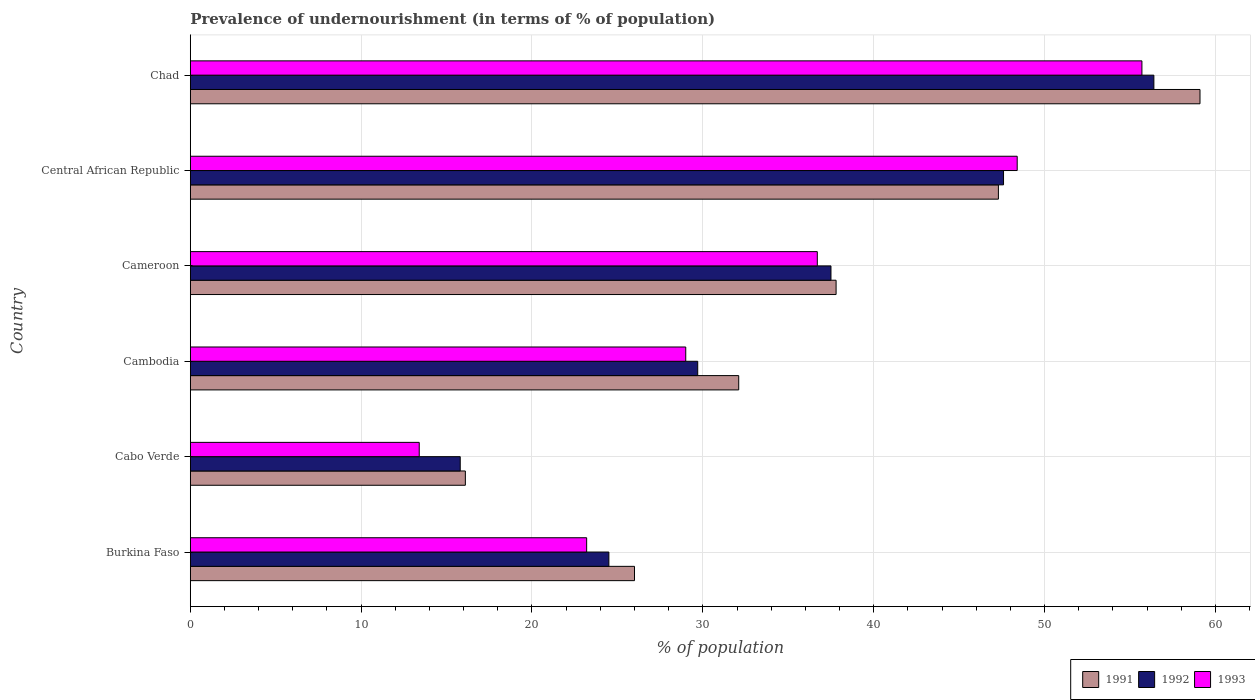How many different coloured bars are there?
Provide a succinct answer. 3. Are the number of bars on each tick of the Y-axis equal?
Make the answer very short. Yes. How many bars are there on the 6th tick from the top?
Provide a short and direct response. 3. How many bars are there on the 6th tick from the bottom?
Your answer should be very brief. 3. What is the label of the 6th group of bars from the top?
Offer a very short reply. Burkina Faso. What is the percentage of undernourished population in 1993 in Cambodia?
Your answer should be compact. 29. Across all countries, what is the maximum percentage of undernourished population in 1992?
Your answer should be very brief. 56.4. Across all countries, what is the minimum percentage of undernourished population in 1991?
Your response must be concise. 16.1. In which country was the percentage of undernourished population in 1993 maximum?
Give a very brief answer. Chad. In which country was the percentage of undernourished population in 1991 minimum?
Make the answer very short. Cabo Verde. What is the total percentage of undernourished population in 1992 in the graph?
Ensure brevity in your answer.  211.5. What is the difference between the percentage of undernourished population in 1993 in Cambodia and that in Central African Republic?
Provide a short and direct response. -19.4. What is the difference between the percentage of undernourished population in 1991 in Cabo Verde and the percentage of undernourished population in 1993 in Cambodia?
Provide a short and direct response. -12.9. What is the average percentage of undernourished population in 1991 per country?
Make the answer very short. 36.4. What is the difference between the percentage of undernourished population in 1992 and percentage of undernourished population in 1991 in Cabo Verde?
Give a very brief answer. -0.3. In how many countries, is the percentage of undernourished population in 1993 greater than 20 %?
Your response must be concise. 5. What is the ratio of the percentage of undernourished population in 1993 in Cambodia to that in Cameroon?
Your answer should be compact. 0.79. Is the percentage of undernourished population in 1992 in Burkina Faso less than that in Cabo Verde?
Your answer should be very brief. No. What is the difference between the highest and the second highest percentage of undernourished population in 1993?
Offer a very short reply. 7.3. What is the difference between the highest and the lowest percentage of undernourished population in 1993?
Provide a short and direct response. 42.3. Is the sum of the percentage of undernourished population in 1993 in Burkina Faso and Cambodia greater than the maximum percentage of undernourished population in 1991 across all countries?
Keep it short and to the point. No. What does the 1st bar from the top in Burkina Faso represents?
Provide a short and direct response. 1993. What does the 2nd bar from the bottom in Chad represents?
Offer a very short reply. 1992. How many bars are there?
Make the answer very short. 18. How many countries are there in the graph?
Your response must be concise. 6. Are the values on the major ticks of X-axis written in scientific E-notation?
Offer a terse response. No. Does the graph contain any zero values?
Provide a succinct answer. No. Where does the legend appear in the graph?
Ensure brevity in your answer.  Bottom right. How many legend labels are there?
Provide a short and direct response. 3. How are the legend labels stacked?
Your answer should be very brief. Horizontal. What is the title of the graph?
Give a very brief answer. Prevalence of undernourishment (in terms of % of population). What is the label or title of the X-axis?
Your answer should be very brief. % of population. What is the % of population of 1992 in Burkina Faso?
Your response must be concise. 24.5. What is the % of population of 1993 in Burkina Faso?
Your response must be concise. 23.2. What is the % of population in 1991 in Cambodia?
Give a very brief answer. 32.1. What is the % of population of 1992 in Cambodia?
Offer a terse response. 29.7. What is the % of population in 1991 in Cameroon?
Provide a succinct answer. 37.8. What is the % of population of 1992 in Cameroon?
Provide a short and direct response. 37.5. What is the % of population of 1993 in Cameroon?
Provide a short and direct response. 36.7. What is the % of population of 1991 in Central African Republic?
Your answer should be compact. 47.3. What is the % of population in 1992 in Central African Republic?
Give a very brief answer. 47.6. What is the % of population of 1993 in Central African Republic?
Ensure brevity in your answer.  48.4. What is the % of population in 1991 in Chad?
Provide a succinct answer. 59.1. What is the % of population of 1992 in Chad?
Offer a terse response. 56.4. What is the % of population of 1993 in Chad?
Make the answer very short. 55.7. Across all countries, what is the maximum % of population in 1991?
Give a very brief answer. 59.1. Across all countries, what is the maximum % of population of 1992?
Ensure brevity in your answer.  56.4. Across all countries, what is the maximum % of population of 1993?
Your answer should be very brief. 55.7. Across all countries, what is the minimum % of population in 1991?
Keep it short and to the point. 16.1. Across all countries, what is the minimum % of population of 1993?
Offer a terse response. 13.4. What is the total % of population in 1991 in the graph?
Keep it short and to the point. 218.4. What is the total % of population in 1992 in the graph?
Keep it short and to the point. 211.5. What is the total % of population in 1993 in the graph?
Your answer should be very brief. 206.4. What is the difference between the % of population of 1992 in Burkina Faso and that in Cabo Verde?
Provide a succinct answer. 8.7. What is the difference between the % of population of 1991 in Burkina Faso and that in Cambodia?
Give a very brief answer. -6.1. What is the difference between the % of population of 1991 in Burkina Faso and that in Cameroon?
Offer a very short reply. -11.8. What is the difference between the % of population in 1992 in Burkina Faso and that in Cameroon?
Provide a succinct answer. -13. What is the difference between the % of population of 1993 in Burkina Faso and that in Cameroon?
Provide a succinct answer. -13.5. What is the difference between the % of population in 1991 in Burkina Faso and that in Central African Republic?
Ensure brevity in your answer.  -21.3. What is the difference between the % of population of 1992 in Burkina Faso and that in Central African Republic?
Offer a very short reply. -23.1. What is the difference between the % of population of 1993 in Burkina Faso and that in Central African Republic?
Provide a short and direct response. -25.2. What is the difference between the % of population of 1991 in Burkina Faso and that in Chad?
Give a very brief answer. -33.1. What is the difference between the % of population in 1992 in Burkina Faso and that in Chad?
Provide a short and direct response. -31.9. What is the difference between the % of population in 1993 in Burkina Faso and that in Chad?
Your response must be concise. -32.5. What is the difference between the % of population of 1991 in Cabo Verde and that in Cambodia?
Provide a short and direct response. -16. What is the difference between the % of population in 1993 in Cabo Verde and that in Cambodia?
Keep it short and to the point. -15.6. What is the difference between the % of population of 1991 in Cabo Verde and that in Cameroon?
Ensure brevity in your answer.  -21.7. What is the difference between the % of population in 1992 in Cabo Verde and that in Cameroon?
Offer a very short reply. -21.7. What is the difference between the % of population in 1993 in Cabo Verde and that in Cameroon?
Your answer should be compact. -23.3. What is the difference between the % of population in 1991 in Cabo Verde and that in Central African Republic?
Keep it short and to the point. -31.2. What is the difference between the % of population in 1992 in Cabo Verde and that in Central African Republic?
Offer a terse response. -31.8. What is the difference between the % of population in 1993 in Cabo Verde and that in Central African Republic?
Offer a terse response. -35. What is the difference between the % of population of 1991 in Cabo Verde and that in Chad?
Your answer should be very brief. -43. What is the difference between the % of population of 1992 in Cabo Verde and that in Chad?
Ensure brevity in your answer.  -40.6. What is the difference between the % of population of 1993 in Cabo Verde and that in Chad?
Give a very brief answer. -42.3. What is the difference between the % of population of 1992 in Cambodia and that in Cameroon?
Offer a terse response. -7.8. What is the difference between the % of population of 1991 in Cambodia and that in Central African Republic?
Keep it short and to the point. -15.2. What is the difference between the % of population of 1992 in Cambodia and that in Central African Republic?
Give a very brief answer. -17.9. What is the difference between the % of population in 1993 in Cambodia and that in Central African Republic?
Ensure brevity in your answer.  -19.4. What is the difference between the % of population in 1992 in Cambodia and that in Chad?
Make the answer very short. -26.7. What is the difference between the % of population in 1993 in Cambodia and that in Chad?
Offer a very short reply. -26.7. What is the difference between the % of population in 1993 in Cameroon and that in Central African Republic?
Offer a terse response. -11.7. What is the difference between the % of population of 1991 in Cameroon and that in Chad?
Offer a terse response. -21.3. What is the difference between the % of population in 1992 in Cameroon and that in Chad?
Your answer should be compact. -18.9. What is the difference between the % of population of 1991 in Burkina Faso and the % of population of 1993 in Cabo Verde?
Ensure brevity in your answer.  12.6. What is the difference between the % of population of 1992 in Burkina Faso and the % of population of 1993 in Cabo Verde?
Offer a terse response. 11.1. What is the difference between the % of population of 1991 in Burkina Faso and the % of population of 1993 in Cambodia?
Provide a succinct answer. -3. What is the difference between the % of population in 1992 in Burkina Faso and the % of population in 1993 in Cambodia?
Make the answer very short. -4.5. What is the difference between the % of population in 1991 in Burkina Faso and the % of population in 1992 in Cameroon?
Provide a succinct answer. -11.5. What is the difference between the % of population in 1991 in Burkina Faso and the % of population in 1993 in Cameroon?
Provide a succinct answer. -10.7. What is the difference between the % of population in 1991 in Burkina Faso and the % of population in 1992 in Central African Republic?
Provide a succinct answer. -21.6. What is the difference between the % of population of 1991 in Burkina Faso and the % of population of 1993 in Central African Republic?
Your answer should be compact. -22.4. What is the difference between the % of population of 1992 in Burkina Faso and the % of population of 1993 in Central African Republic?
Offer a terse response. -23.9. What is the difference between the % of population of 1991 in Burkina Faso and the % of population of 1992 in Chad?
Your answer should be compact. -30.4. What is the difference between the % of population of 1991 in Burkina Faso and the % of population of 1993 in Chad?
Your response must be concise. -29.7. What is the difference between the % of population in 1992 in Burkina Faso and the % of population in 1993 in Chad?
Provide a short and direct response. -31.2. What is the difference between the % of population of 1991 in Cabo Verde and the % of population of 1993 in Cambodia?
Keep it short and to the point. -12.9. What is the difference between the % of population of 1991 in Cabo Verde and the % of population of 1992 in Cameroon?
Provide a short and direct response. -21.4. What is the difference between the % of population in 1991 in Cabo Verde and the % of population in 1993 in Cameroon?
Offer a very short reply. -20.6. What is the difference between the % of population of 1992 in Cabo Verde and the % of population of 1993 in Cameroon?
Offer a terse response. -20.9. What is the difference between the % of population in 1991 in Cabo Verde and the % of population in 1992 in Central African Republic?
Offer a very short reply. -31.5. What is the difference between the % of population in 1991 in Cabo Verde and the % of population in 1993 in Central African Republic?
Provide a succinct answer. -32.3. What is the difference between the % of population in 1992 in Cabo Verde and the % of population in 1993 in Central African Republic?
Ensure brevity in your answer.  -32.6. What is the difference between the % of population of 1991 in Cabo Verde and the % of population of 1992 in Chad?
Keep it short and to the point. -40.3. What is the difference between the % of population of 1991 in Cabo Verde and the % of population of 1993 in Chad?
Provide a short and direct response. -39.6. What is the difference between the % of population in 1992 in Cabo Verde and the % of population in 1993 in Chad?
Offer a terse response. -39.9. What is the difference between the % of population in 1991 in Cambodia and the % of population in 1993 in Cameroon?
Your answer should be very brief. -4.6. What is the difference between the % of population in 1991 in Cambodia and the % of population in 1992 in Central African Republic?
Your answer should be compact. -15.5. What is the difference between the % of population of 1991 in Cambodia and the % of population of 1993 in Central African Republic?
Provide a succinct answer. -16.3. What is the difference between the % of population in 1992 in Cambodia and the % of population in 1993 in Central African Republic?
Provide a succinct answer. -18.7. What is the difference between the % of population of 1991 in Cambodia and the % of population of 1992 in Chad?
Keep it short and to the point. -24.3. What is the difference between the % of population in 1991 in Cambodia and the % of population in 1993 in Chad?
Your answer should be compact. -23.6. What is the difference between the % of population in 1992 in Cambodia and the % of population in 1993 in Chad?
Provide a short and direct response. -26. What is the difference between the % of population of 1991 in Cameroon and the % of population of 1992 in Central African Republic?
Your response must be concise. -9.8. What is the difference between the % of population in 1991 in Cameroon and the % of population in 1993 in Central African Republic?
Offer a terse response. -10.6. What is the difference between the % of population of 1992 in Cameroon and the % of population of 1993 in Central African Republic?
Make the answer very short. -10.9. What is the difference between the % of population of 1991 in Cameroon and the % of population of 1992 in Chad?
Make the answer very short. -18.6. What is the difference between the % of population in 1991 in Cameroon and the % of population in 1993 in Chad?
Make the answer very short. -17.9. What is the difference between the % of population of 1992 in Cameroon and the % of population of 1993 in Chad?
Your response must be concise. -18.2. What is the difference between the % of population of 1991 in Central African Republic and the % of population of 1992 in Chad?
Your answer should be very brief. -9.1. What is the average % of population in 1991 per country?
Make the answer very short. 36.4. What is the average % of population of 1992 per country?
Offer a very short reply. 35.25. What is the average % of population in 1993 per country?
Your answer should be compact. 34.4. What is the difference between the % of population of 1992 and % of population of 1993 in Burkina Faso?
Ensure brevity in your answer.  1.3. What is the difference between the % of population of 1991 and % of population of 1993 in Cabo Verde?
Ensure brevity in your answer.  2.7. What is the difference between the % of population in 1991 and % of population in 1993 in Cameroon?
Offer a terse response. 1.1. What is the difference between the % of population in 1992 and % of population in 1993 in Cameroon?
Your answer should be compact. 0.8. What is the difference between the % of population of 1992 and % of population of 1993 in Chad?
Offer a very short reply. 0.7. What is the ratio of the % of population in 1991 in Burkina Faso to that in Cabo Verde?
Offer a very short reply. 1.61. What is the ratio of the % of population in 1992 in Burkina Faso to that in Cabo Verde?
Ensure brevity in your answer.  1.55. What is the ratio of the % of population of 1993 in Burkina Faso to that in Cabo Verde?
Provide a succinct answer. 1.73. What is the ratio of the % of population of 1991 in Burkina Faso to that in Cambodia?
Your answer should be compact. 0.81. What is the ratio of the % of population of 1992 in Burkina Faso to that in Cambodia?
Give a very brief answer. 0.82. What is the ratio of the % of population of 1993 in Burkina Faso to that in Cambodia?
Give a very brief answer. 0.8. What is the ratio of the % of population in 1991 in Burkina Faso to that in Cameroon?
Your answer should be very brief. 0.69. What is the ratio of the % of population in 1992 in Burkina Faso to that in Cameroon?
Your response must be concise. 0.65. What is the ratio of the % of population in 1993 in Burkina Faso to that in Cameroon?
Your answer should be very brief. 0.63. What is the ratio of the % of population in 1991 in Burkina Faso to that in Central African Republic?
Ensure brevity in your answer.  0.55. What is the ratio of the % of population of 1992 in Burkina Faso to that in Central African Republic?
Your response must be concise. 0.51. What is the ratio of the % of population in 1993 in Burkina Faso to that in Central African Republic?
Give a very brief answer. 0.48. What is the ratio of the % of population in 1991 in Burkina Faso to that in Chad?
Your answer should be compact. 0.44. What is the ratio of the % of population of 1992 in Burkina Faso to that in Chad?
Give a very brief answer. 0.43. What is the ratio of the % of population of 1993 in Burkina Faso to that in Chad?
Offer a terse response. 0.42. What is the ratio of the % of population of 1991 in Cabo Verde to that in Cambodia?
Keep it short and to the point. 0.5. What is the ratio of the % of population of 1992 in Cabo Verde to that in Cambodia?
Provide a succinct answer. 0.53. What is the ratio of the % of population in 1993 in Cabo Verde to that in Cambodia?
Your answer should be compact. 0.46. What is the ratio of the % of population in 1991 in Cabo Verde to that in Cameroon?
Keep it short and to the point. 0.43. What is the ratio of the % of population of 1992 in Cabo Verde to that in Cameroon?
Offer a terse response. 0.42. What is the ratio of the % of population in 1993 in Cabo Verde to that in Cameroon?
Provide a short and direct response. 0.37. What is the ratio of the % of population in 1991 in Cabo Verde to that in Central African Republic?
Offer a very short reply. 0.34. What is the ratio of the % of population of 1992 in Cabo Verde to that in Central African Republic?
Ensure brevity in your answer.  0.33. What is the ratio of the % of population of 1993 in Cabo Verde to that in Central African Republic?
Offer a terse response. 0.28. What is the ratio of the % of population in 1991 in Cabo Verde to that in Chad?
Make the answer very short. 0.27. What is the ratio of the % of population in 1992 in Cabo Verde to that in Chad?
Your response must be concise. 0.28. What is the ratio of the % of population of 1993 in Cabo Verde to that in Chad?
Keep it short and to the point. 0.24. What is the ratio of the % of population in 1991 in Cambodia to that in Cameroon?
Give a very brief answer. 0.85. What is the ratio of the % of population in 1992 in Cambodia to that in Cameroon?
Give a very brief answer. 0.79. What is the ratio of the % of population of 1993 in Cambodia to that in Cameroon?
Keep it short and to the point. 0.79. What is the ratio of the % of population of 1991 in Cambodia to that in Central African Republic?
Provide a short and direct response. 0.68. What is the ratio of the % of population in 1992 in Cambodia to that in Central African Republic?
Make the answer very short. 0.62. What is the ratio of the % of population of 1993 in Cambodia to that in Central African Republic?
Keep it short and to the point. 0.6. What is the ratio of the % of population in 1991 in Cambodia to that in Chad?
Provide a succinct answer. 0.54. What is the ratio of the % of population of 1992 in Cambodia to that in Chad?
Your answer should be compact. 0.53. What is the ratio of the % of population of 1993 in Cambodia to that in Chad?
Make the answer very short. 0.52. What is the ratio of the % of population in 1991 in Cameroon to that in Central African Republic?
Your answer should be very brief. 0.8. What is the ratio of the % of population of 1992 in Cameroon to that in Central African Republic?
Ensure brevity in your answer.  0.79. What is the ratio of the % of population of 1993 in Cameroon to that in Central African Republic?
Your response must be concise. 0.76. What is the ratio of the % of population of 1991 in Cameroon to that in Chad?
Your answer should be compact. 0.64. What is the ratio of the % of population in 1992 in Cameroon to that in Chad?
Your response must be concise. 0.66. What is the ratio of the % of population of 1993 in Cameroon to that in Chad?
Give a very brief answer. 0.66. What is the ratio of the % of population in 1991 in Central African Republic to that in Chad?
Provide a succinct answer. 0.8. What is the ratio of the % of population in 1992 in Central African Republic to that in Chad?
Provide a short and direct response. 0.84. What is the ratio of the % of population of 1993 in Central African Republic to that in Chad?
Give a very brief answer. 0.87. What is the difference between the highest and the second highest % of population of 1992?
Offer a terse response. 8.8. What is the difference between the highest and the lowest % of population in 1991?
Make the answer very short. 43. What is the difference between the highest and the lowest % of population of 1992?
Provide a short and direct response. 40.6. What is the difference between the highest and the lowest % of population of 1993?
Your response must be concise. 42.3. 